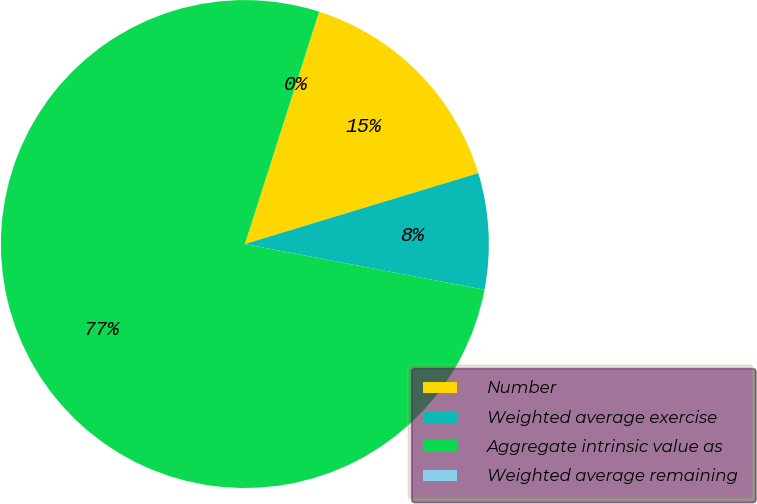Convert chart to OTSL. <chart><loc_0><loc_0><loc_500><loc_500><pie_chart><fcel>Number<fcel>Weighted average exercise<fcel>Aggregate intrinsic value as<fcel>Weighted average remaining<nl><fcel>15.38%<fcel>7.69%<fcel>76.92%<fcel>0.0%<nl></chart> 